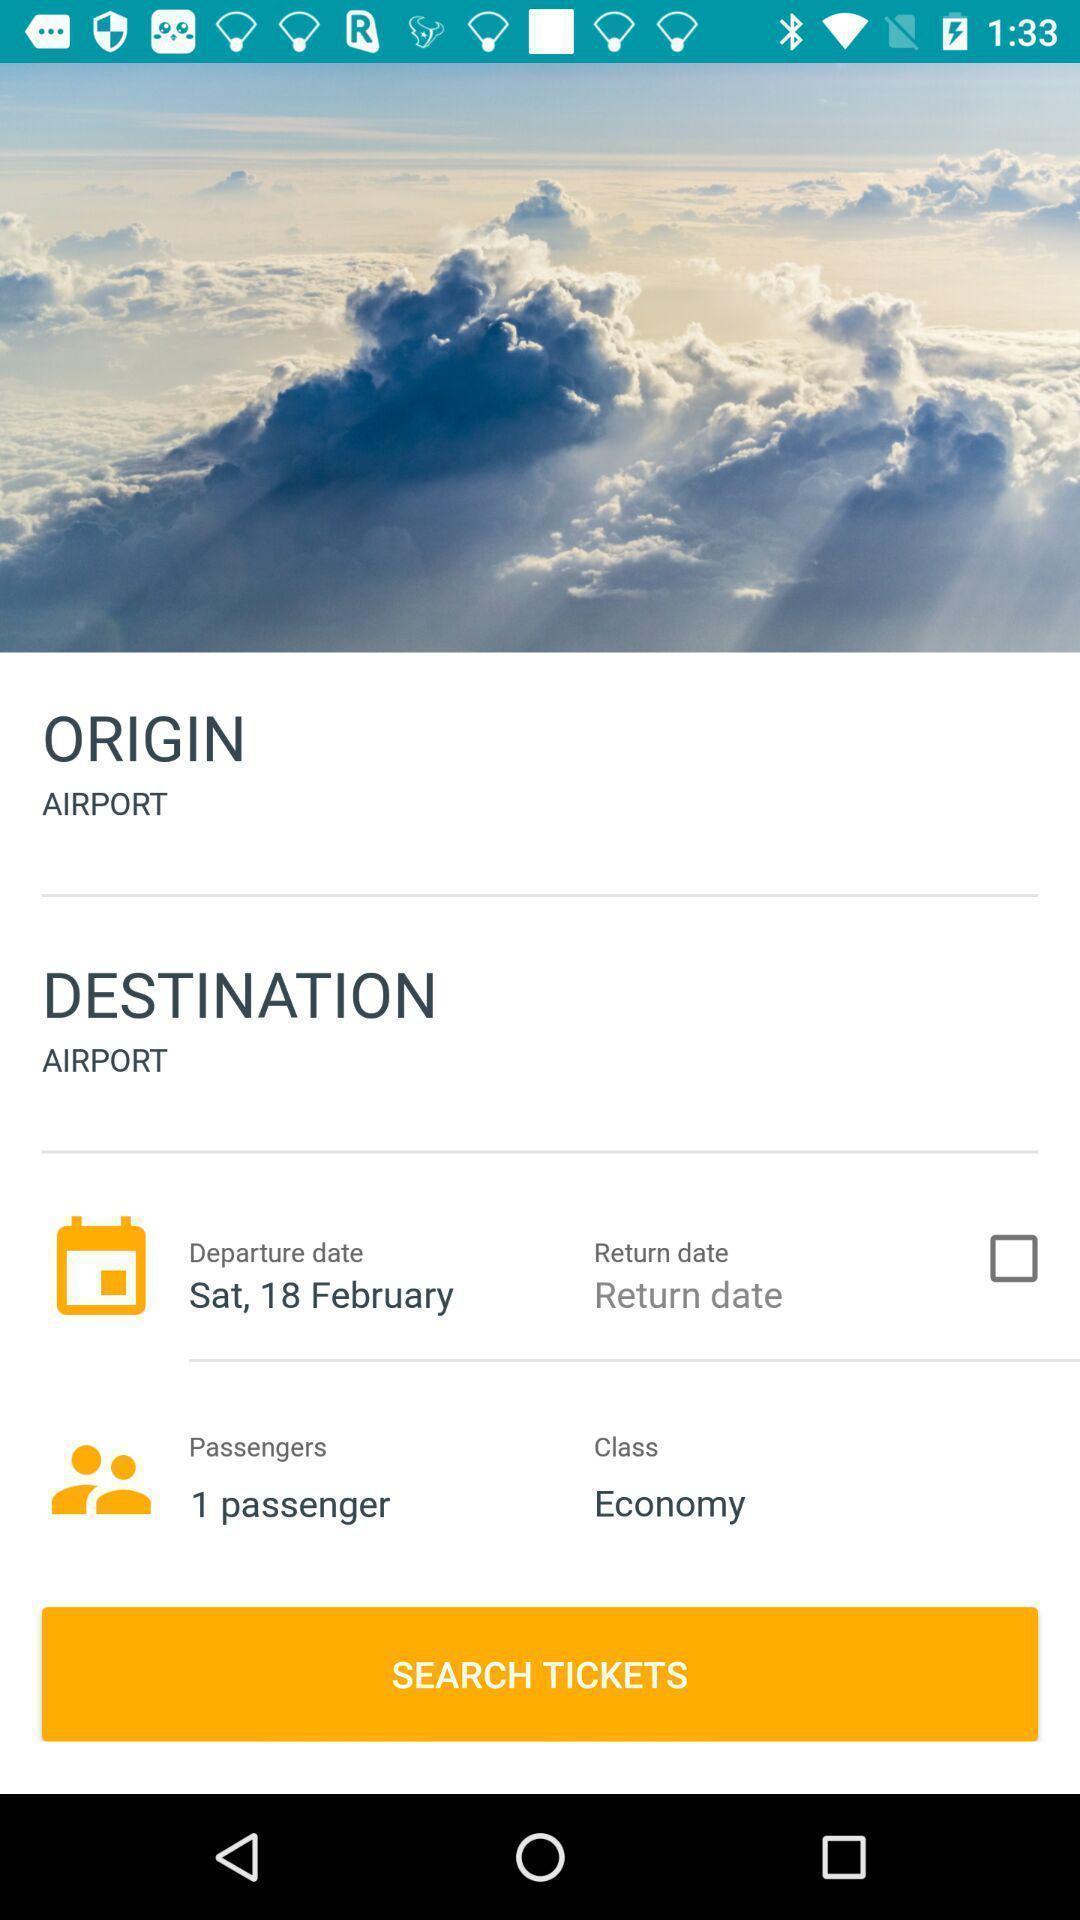Provide a detailed account of this screenshot. Screen shows multiple options in a travel app. 